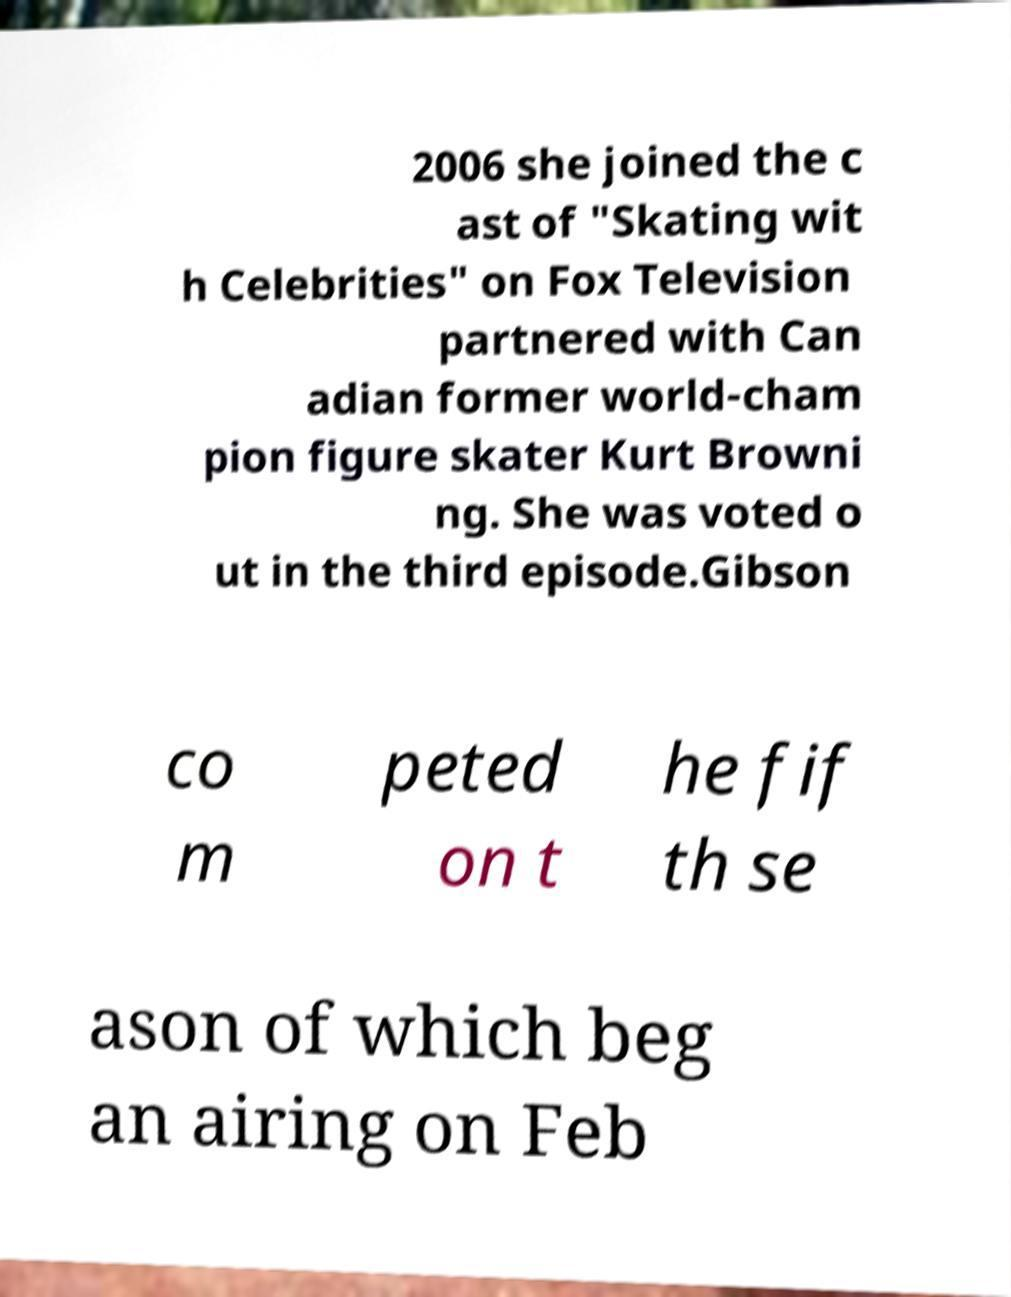Please identify and transcribe the text found in this image. 2006 she joined the c ast of "Skating wit h Celebrities" on Fox Television partnered with Can adian former world-cham pion figure skater Kurt Browni ng. She was voted o ut in the third episode.Gibson co m peted on t he fif th se ason of which beg an airing on Feb 